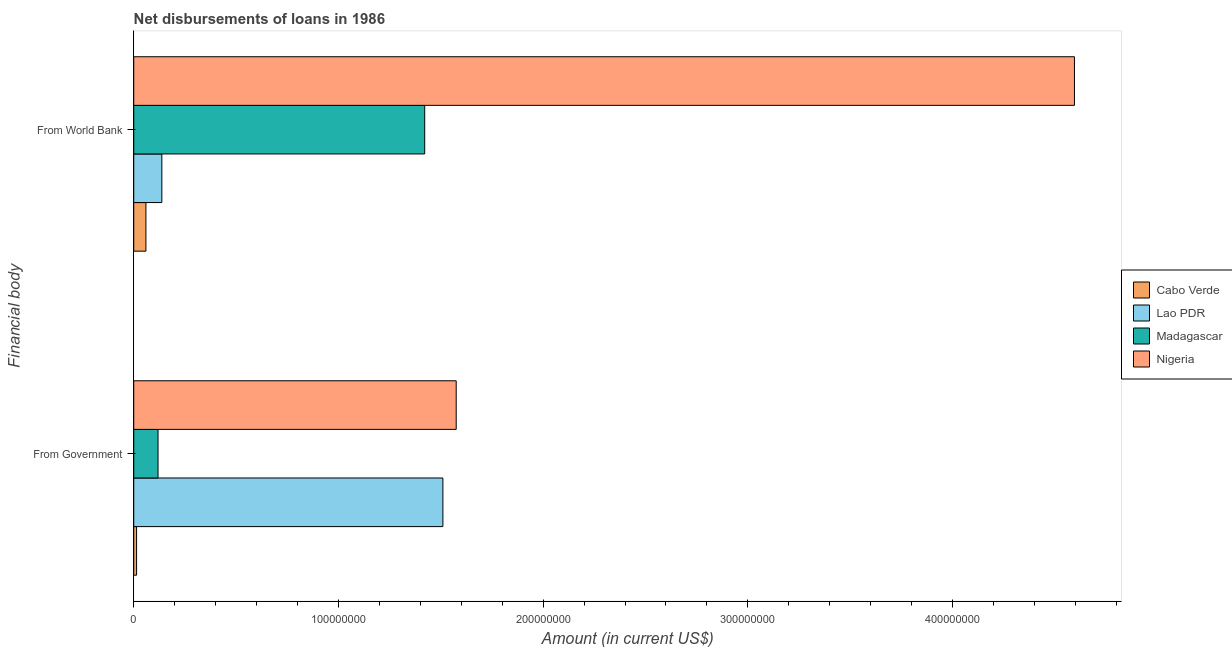How many groups of bars are there?
Make the answer very short. 2. Are the number of bars on each tick of the Y-axis equal?
Keep it short and to the point. Yes. How many bars are there on the 1st tick from the top?
Provide a short and direct response. 4. How many bars are there on the 1st tick from the bottom?
Offer a terse response. 4. What is the label of the 2nd group of bars from the top?
Provide a short and direct response. From Government. What is the net disbursements of loan from government in Lao PDR?
Offer a very short reply. 1.51e+08. Across all countries, what is the maximum net disbursements of loan from government?
Your answer should be very brief. 1.58e+08. Across all countries, what is the minimum net disbursements of loan from government?
Ensure brevity in your answer.  1.39e+06. In which country was the net disbursements of loan from world bank maximum?
Provide a short and direct response. Nigeria. In which country was the net disbursements of loan from government minimum?
Give a very brief answer. Cabo Verde. What is the total net disbursements of loan from world bank in the graph?
Your answer should be very brief. 6.21e+08. What is the difference between the net disbursements of loan from world bank in Cabo Verde and that in Lao PDR?
Keep it short and to the point. -7.77e+06. What is the difference between the net disbursements of loan from world bank in Lao PDR and the net disbursements of loan from government in Madagascar?
Offer a terse response. 1.86e+06. What is the average net disbursements of loan from world bank per country?
Make the answer very short. 1.55e+08. What is the difference between the net disbursements of loan from world bank and net disbursements of loan from government in Nigeria?
Your answer should be very brief. 3.02e+08. In how many countries, is the net disbursements of loan from world bank greater than 100000000 US$?
Give a very brief answer. 2. What is the ratio of the net disbursements of loan from world bank in Madagascar to that in Nigeria?
Provide a short and direct response. 0.31. Is the net disbursements of loan from government in Lao PDR less than that in Cabo Verde?
Offer a terse response. No. In how many countries, is the net disbursements of loan from government greater than the average net disbursements of loan from government taken over all countries?
Offer a very short reply. 2. What does the 3rd bar from the top in From Government represents?
Your answer should be very brief. Lao PDR. What does the 1st bar from the bottom in From World Bank represents?
Your answer should be compact. Cabo Verde. What is the difference between two consecutive major ticks on the X-axis?
Give a very brief answer. 1.00e+08. Does the graph contain any zero values?
Keep it short and to the point. No. Does the graph contain grids?
Your answer should be very brief. No. Where does the legend appear in the graph?
Make the answer very short. Center right. What is the title of the graph?
Your answer should be very brief. Net disbursements of loans in 1986. Does "Namibia" appear as one of the legend labels in the graph?
Provide a succinct answer. No. What is the label or title of the X-axis?
Provide a short and direct response. Amount (in current US$). What is the label or title of the Y-axis?
Your answer should be compact. Financial body. What is the Amount (in current US$) in Cabo Verde in From Government?
Ensure brevity in your answer.  1.39e+06. What is the Amount (in current US$) of Lao PDR in From Government?
Your response must be concise. 1.51e+08. What is the Amount (in current US$) of Madagascar in From Government?
Your answer should be compact. 1.19e+07. What is the Amount (in current US$) in Nigeria in From Government?
Your answer should be very brief. 1.58e+08. What is the Amount (in current US$) of Cabo Verde in From World Bank?
Your answer should be compact. 5.95e+06. What is the Amount (in current US$) of Lao PDR in From World Bank?
Make the answer very short. 1.37e+07. What is the Amount (in current US$) of Madagascar in From World Bank?
Your answer should be very brief. 1.42e+08. What is the Amount (in current US$) in Nigeria in From World Bank?
Give a very brief answer. 4.60e+08. Across all Financial body, what is the maximum Amount (in current US$) of Cabo Verde?
Your response must be concise. 5.95e+06. Across all Financial body, what is the maximum Amount (in current US$) in Lao PDR?
Provide a short and direct response. 1.51e+08. Across all Financial body, what is the maximum Amount (in current US$) in Madagascar?
Give a very brief answer. 1.42e+08. Across all Financial body, what is the maximum Amount (in current US$) in Nigeria?
Your answer should be very brief. 4.60e+08. Across all Financial body, what is the minimum Amount (in current US$) in Cabo Verde?
Provide a succinct answer. 1.39e+06. Across all Financial body, what is the minimum Amount (in current US$) of Lao PDR?
Provide a succinct answer. 1.37e+07. Across all Financial body, what is the minimum Amount (in current US$) in Madagascar?
Your answer should be compact. 1.19e+07. Across all Financial body, what is the minimum Amount (in current US$) of Nigeria?
Provide a succinct answer. 1.58e+08. What is the total Amount (in current US$) of Cabo Verde in the graph?
Offer a very short reply. 7.34e+06. What is the total Amount (in current US$) in Lao PDR in the graph?
Your response must be concise. 1.65e+08. What is the total Amount (in current US$) in Madagascar in the graph?
Provide a short and direct response. 1.54e+08. What is the total Amount (in current US$) in Nigeria in the graph?
Your answer should be compact. 6.17e+08. What is the difference between the Amount (in current US$) in Cabo Verde in From Government and that in From World Bank?
Keep it short and to the point. -4.56e+06. What is the difference between the Amount (in current US$) in Lao PDR in From Government and that in From World Bank?
Offer a very short reply. 1.37e+08. What is the difference between the Amount (in current US$) in Madagascar in From Government and that in From World Bank?
Provide a succinct answer. -1.30e+08. What is the difference between the Amount (in current US$) of Nigeria in From Government and that in From World Bank?
Keep it short and to the point. -3.02e+08. What is the difference between the Amount (in current US$) of Cabo Verde in From Government and the Amount (in current US$) of Lao PDR in From World Bank?
Provide a short and direct response. -1.23e+07. What is the difference between the Amount (in current US$) of Cabo Verde in From Government and the Amount (in current US$) of Madagascar in From World Bank?
Offer a terse response. -1.41e+08. What is the difference between the Amount (in current US$) in Cabo Verde in From Government and the Amount (in current US$) in Nigeria in From World Bank?
Offer a terse response. -4.58e+08. What is the difference between the Amount (in current US$) of Lao PDR in From Government and the Amount (in current US$) of Madagascar in From World Bank?
Offer a very short reply. 8.88e+06. What is the difference between the Amount (in current US$) of Lao PDR in From Government and the Amount (in current US$) of Nigeria in From World Bank?
Give a very brief answer. -3.09e+08. What is the difference between the Amount (in current US$) in Madagascar in From Government and the Amount (in current US$) in Nigeria in From World Bank?
Provide a short and direct response. -4.48e+08. What is the average Amount (in current US$) in Cabo Verde per Financial body?
Make the answer very short. 3.67e+06. What is the average Amount (in current US$) in Lao PDR per Financial body?
Make the answer very short. 8.24e+07. What is the average Amount (in current US$) of Madagascar per Financial body?
Provide a short and direct response. 7.70e+07. What is the average Amount (in current US$) in Nigeria per Financial body?
Make the answer very short. 3.09e+08. What is the difference between the Amount (in current US$) in Cabo Verde and Amount (in current US$) in Lao PDR in From Government?
Give a very brief answer. -1.50e+08. What is the difference between the Amount (in current US$) of Cabo Verde and Amount (in current US$) of Madagascar in From Government?
Offer a very short reply. -1.05e+07. What is the difference between the Amount (in current US$) in Cabo Verde and Amount (in current US$) in Nigeria in From Government?
Provide a short and direct response. -1.56e+08. What is the difference between the Amount (in current US$) in Lao PDR and Amount (in current US$) in Madagascar in From Government?
Your answer should be very brief. 1.39e+08. What is the difference between the Amount (in current US$) in Lao PDR and Amount (in current US$) in Nigeria in From Government?
Make the answer very short. -6.50e+06. What is the difference between the Amount (in current US$) of Madagascar and Amount (in current US$) of Nigeria in From Government?
Provide a short and direct response. -1.46e+08. What is the difference between the Amount (in current US$) of Cabo Verde and Amount (in current US$) of Lao PDR in From World Bank?
Provide a short and direct response. -7.77e+06. What is the difference between the Amount (in current US$) of Cabo Verde and Amount (in current US$) of Madagascar in From World Bank?
Your answer should be very brief. -1.36e+08. What is the difference between the Amount (in current US$) of Cabo Verde and Amount (in current US$) of Nigeria in From World Bank?
Ensure brevity in your answer.  -4.54e+08. What is the difference between the Amount (in current US$) in Lao PDR and Amount (in current US$) in Madagascar in From World Bank?
Your response must be concise. -1.28e+08. What is the difference between the Amount (in current US$) of Lao PDR and Amount (in current US$) of Nigeria in From World Bank?
Ensure brevity in your answer.  -4.46e+08. What is the difference between the Amount (in current US$) of Madagascar and Amount (in current US$) of Nigeria in From World Bank?
Give a very brief answer. -3.17e+08. What is the ratio of the Amount (in current US$) in Cabo Verde in From Government to that in From World Bank?
Your answer should be compact. 0.23. What is the ratio of the Amount (in current US$) of Lao PDR in From Government to that in From World Bank?
Offer a very short reply. 11. What is the ratio of the Amount (in current US$) in Madagascar in From Government to that in From World Bank?
Provide a short and direct response. 0.08. What is the ratio of the Amount (in current US$) in Nigeria in From Government to that in From World Bank?
Ensure brevity in your answer.  0.34. What is the difference between the highest and the second highest Amount (in current US$) in Cabo Verde?
Provide a succinct answer. 4.56e+06. What is the difference between the highest and the second highest Amount (in current US$) in Lao PDR?
Your answer should be very brief. 1.37e+08. What is the difference between the highest and the second highest Amount (in current US$) in Madagascar?
Ensure brevity in your answer.  1.30e+08. What is the difference between the highest and the second highest Amount (in current US$) in Nigeria?
Give a very brief answer. 3.02e+08. What is the difference between the highest and the lowest Amount (in current US$) in Cabo Verde?
Your response must be concise. 4.56e+06. What is the difference between the highest and the lowest Amount (in current US$) of Lao PDR?
Ensure brevity in your answer.  1.37e+08. What is the difference between the highest and the lowest Amount (in current US$) of Madagascar?
Offer a very short reply. 1.30e+08. What is the difference between the highest and the lowest Amount (in current US$) in Nigeria?
Offer a very short reply. 3.02e+08. 